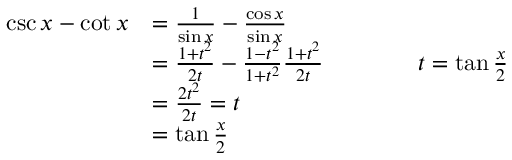<formula> <loc_0><loc_0><loc_500><loc_500>{ \begin{array} { r l } { \csc x - \cot x } & { = { \frac { 1 } { \sin x } } - { \frac { \cos x } { \sin x } } } \\ & { = { \frac { 1 + t ^ { 2 } } { 2 t } } - { \frac { 1 - t ^ { 2 } } { 1 + t ^ { 2 } } } { \frac { 1 + t ^ { 2 } } { 2 t } } \quad t = \tan { \frac { x } { 2 } } } \\ & { = { \frac { 2 t ^ { 2 } } { 2 t } } = t } \\ & { = \tan { \frac { x } { 2 } } } \end{array} }</formula> 